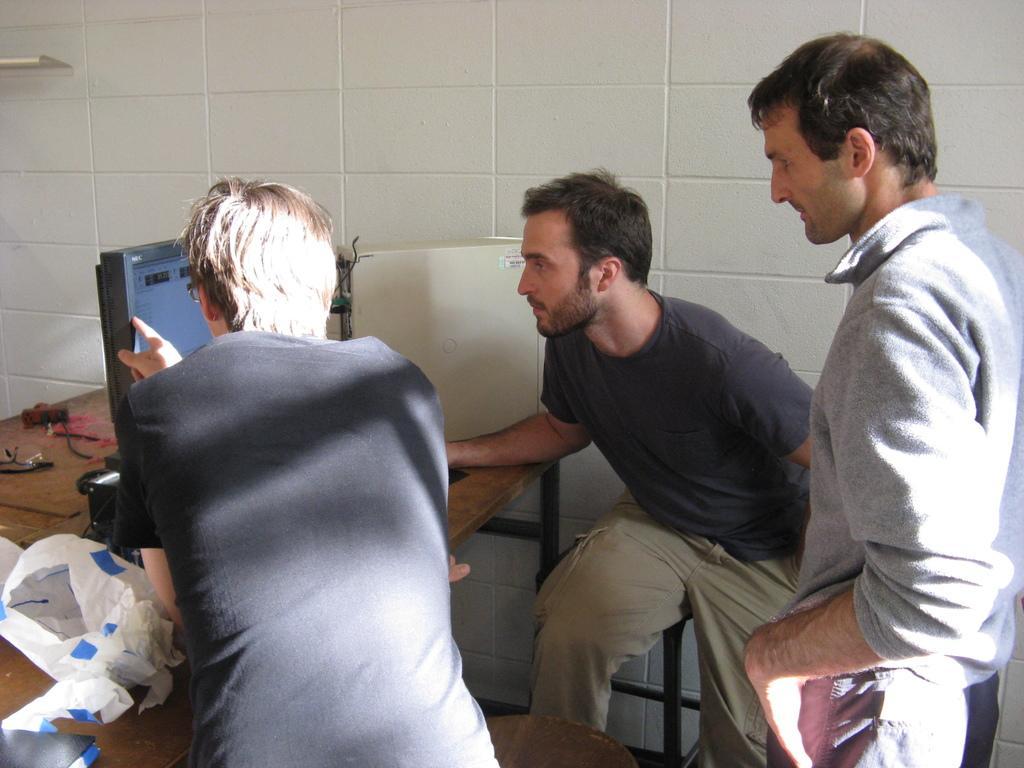Can you describe this image briefly? In this image I can see three men where I can see two of them are wearing black dress and one is wearing grey. I can also see a table and on it I can see a monitor and few white colour things. 